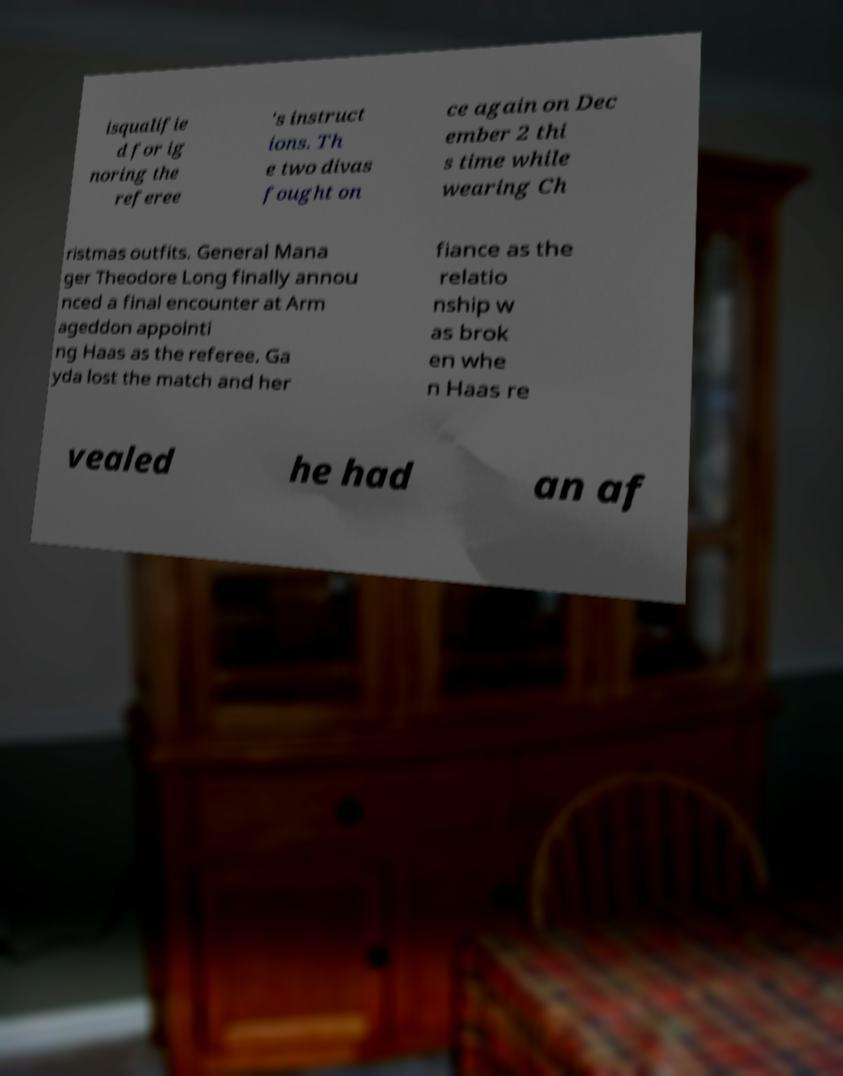Could you assist in decoding the text presented in this image and type it out clearly? isqualifie d for ig noring the referee 's instruct ions. Th e two divas fought on ce again on Dec ember 2 thi s time while wearing Ch ristmas outfits. General Mana ger Theodore Long finally annou nced a final encounter at Arm ageddon appointi ng Haas as the referee. Ga yda lost the match and her fiance as the relatio nship w as brok en whe n Haas re vealed he had an af 